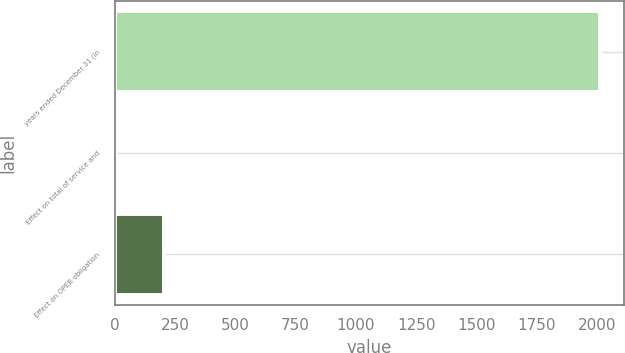Convert chart. <chart><loc_0><loc_0><loc_500><loc_500><bar_chart><fcel>years ended December 31 (in<fcel>Effect on total of service and<fcel>Effect on OPEB obligation<nl><fcel>2012<fcel>4<fcel>204.8<nl></chart> 